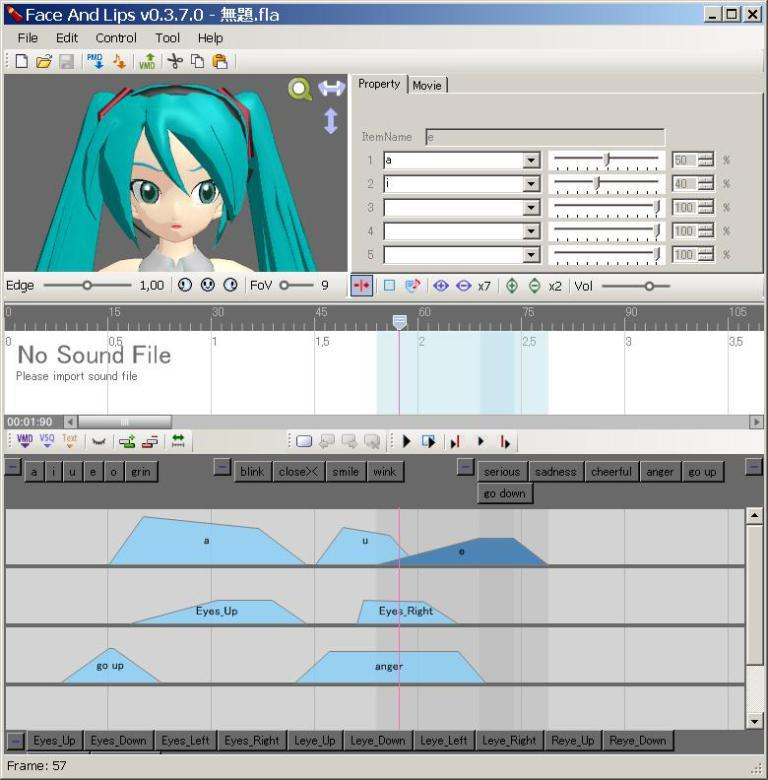What is the main subject of the image? The main subject of the image is a web page. Can you describe any other elements in the image? Yes, there is a cartoon image in the left top corner of the image. How much money is being drained from the cushion in the image? There is no money, drain, or cushion present in the image. 